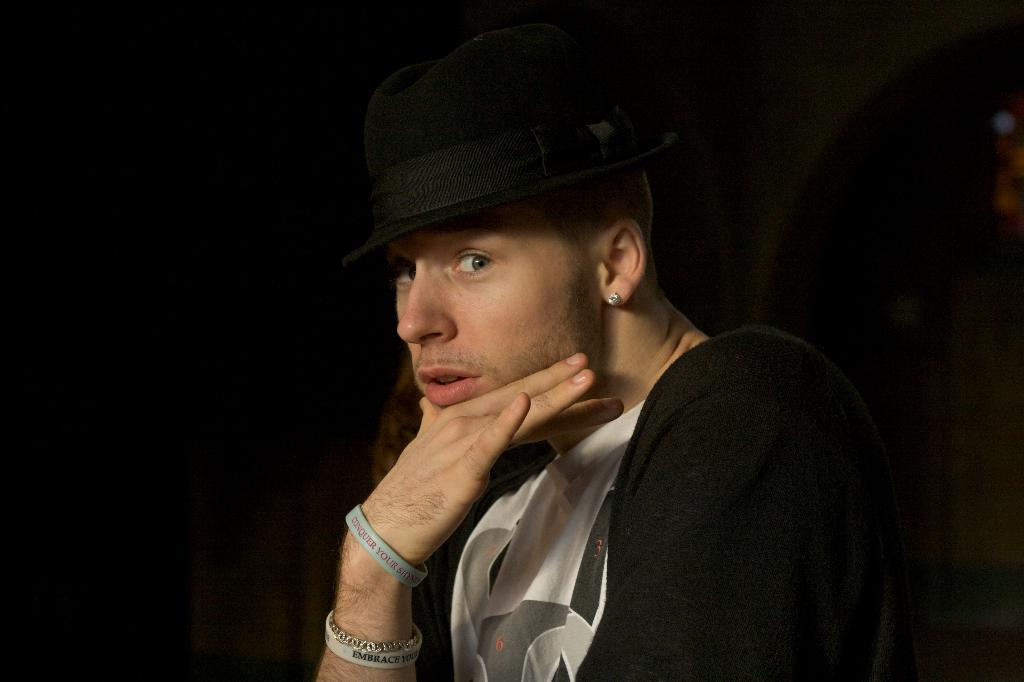Who or what is the main subject of the image? There is a person in the image. What is the person wearing on their head? The person is wearing a cap. Can you describe the background of the image? The background of the image is dark. What type of bean can be seen growing in the image? There is no bean present in the image; it features a person wearing a cap with a dark background. 